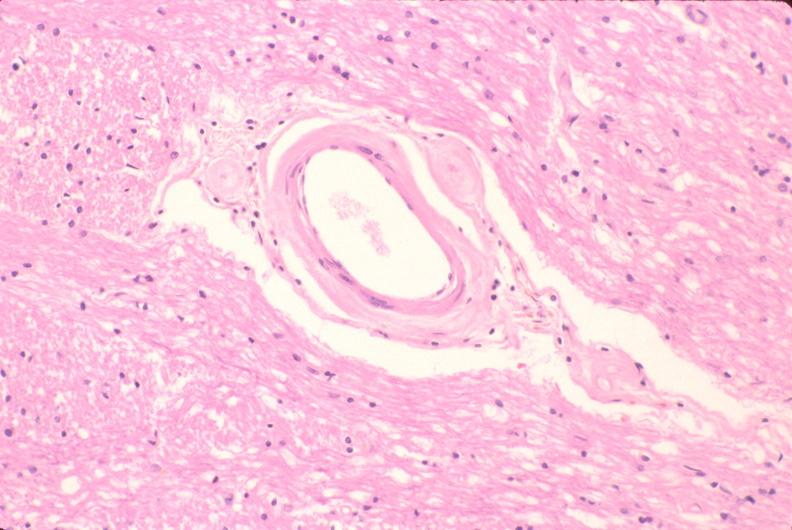does this image show brain, microvessel hyalinization, diabetes mellitus?
Answer the question using a single word or phrase. Yes 